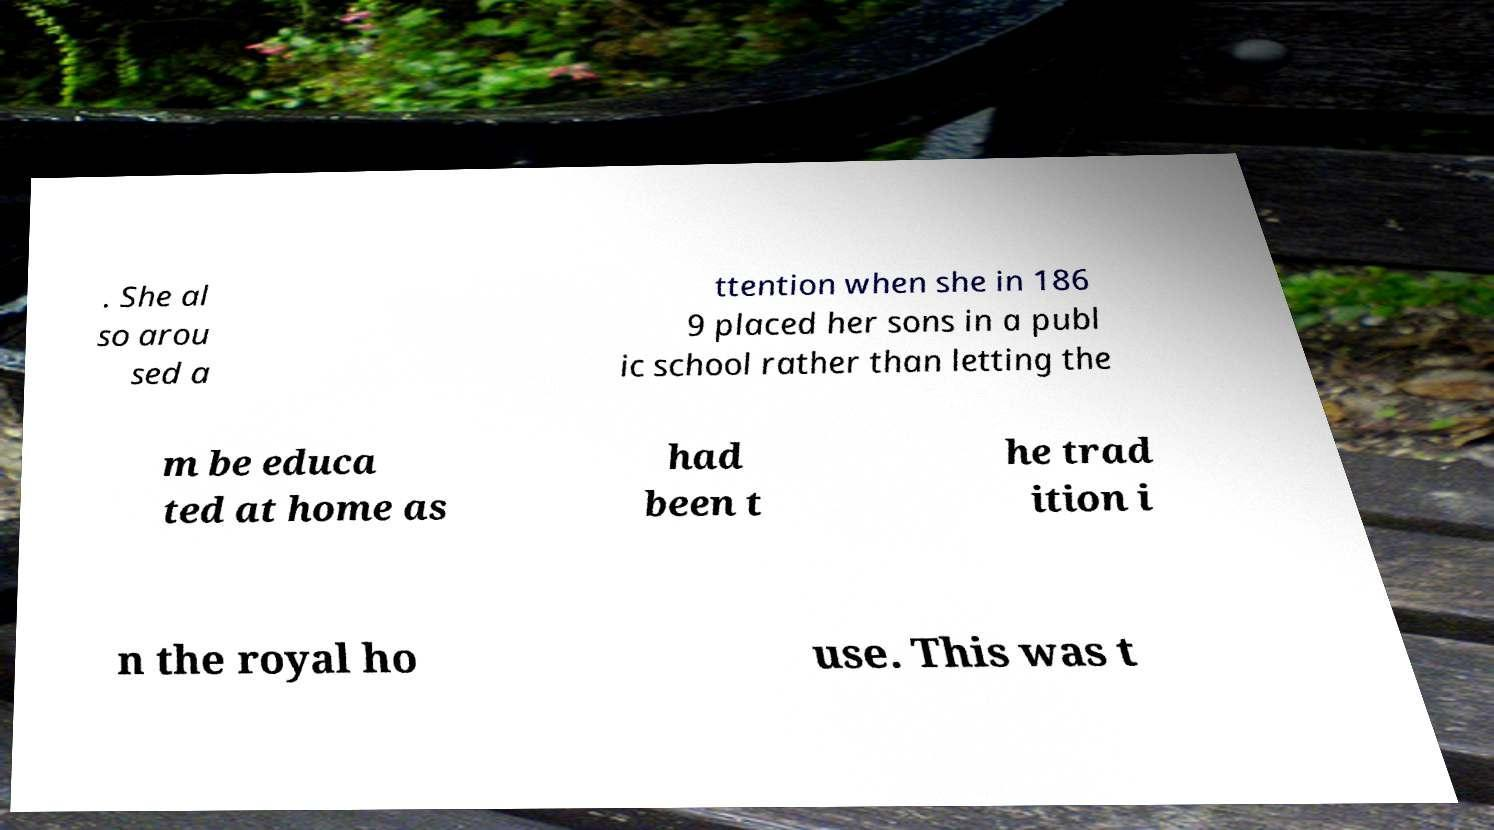Could you assist in decoding the text presented in this image and type it out clearly? . She al so arou sed a ttention when she in 186 9 placed her sons in a publ ic school rather than letting the m be educa ted at home as had been t he trad ition i n the royal ho use. This was t 